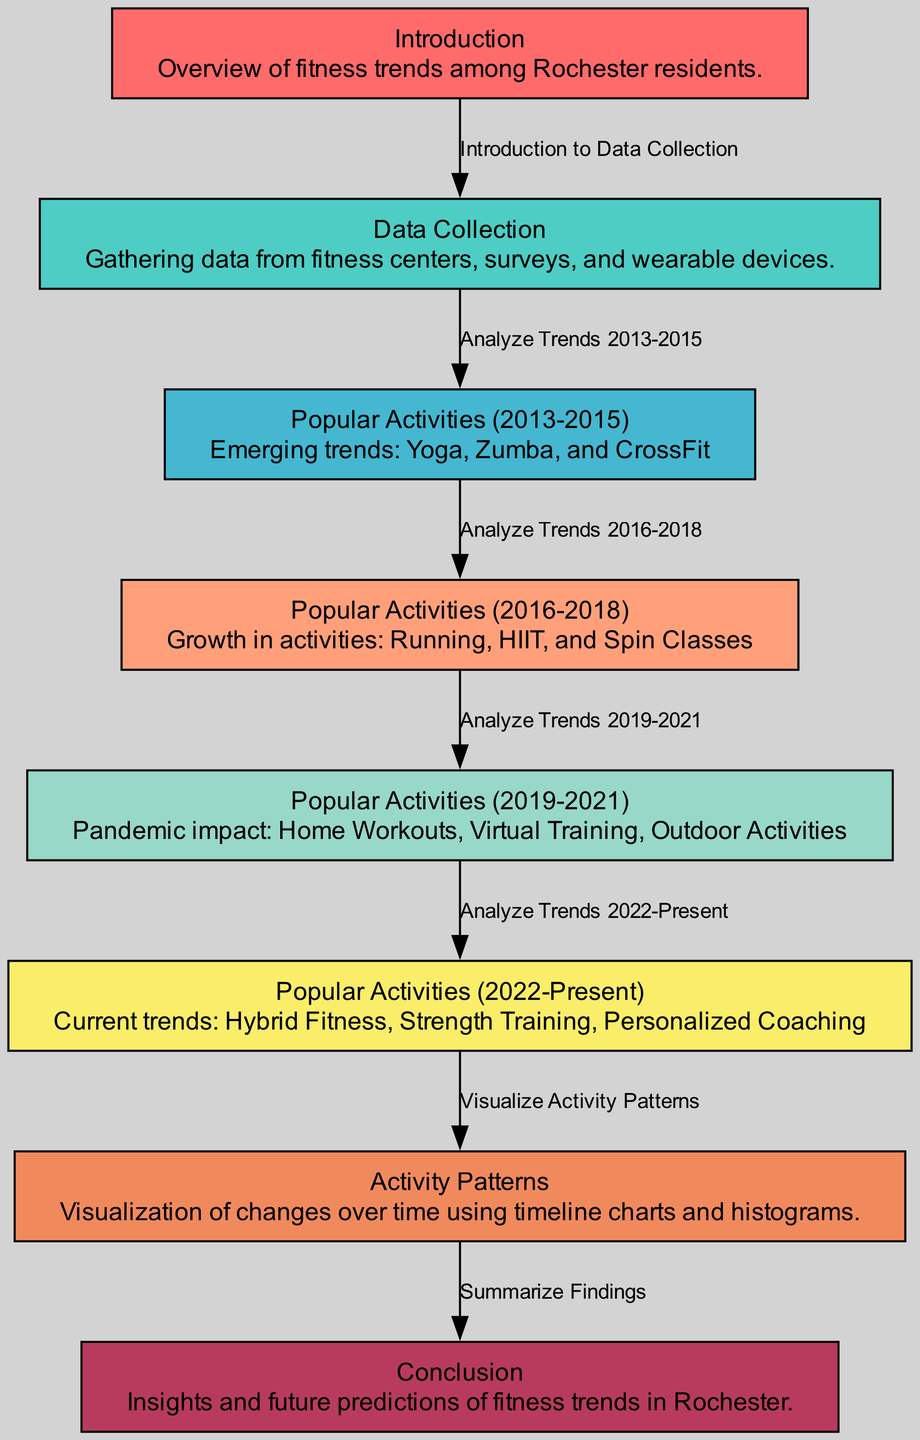What is the label of the first node in the diagram? The first node in the diagram is labeled "Introduction" as stated in the node description.
Answer: Introduction How many nodes are present in the diagram? By counting the entries under the "nodes" section in the data, there are a total of eight nodes in the diagram.
Answer: 8 What is the relationship between the "Data Collection" and "Popular Activities (2013-2015)" nodes? The "Data Collection" node points to "Popular Activities (2013-2015)", indicating that the analysis of trends from 2013 to 2015 follows the data collection process.
Answer: Analyze Trends 2013-2015 What fitness activities emerged as popular from 2013 to 2015? According to the "Popular Activities (2013-2015)" node, the emerging trends include Yoga, Zumba, and CrossFit.
Answer: Yoga, Zumba, and CrossFit What significant fitness change occurred between 2019 and 2021? The "Popular Activities (2019-2021)" node indicates that the pandemic impacted trends, leading to growth in Home Workouts, Virtual Training, and Outdoor Activities during this time.
Answer: Home Workouts, Virtual Training, Outdoor Activities Which node discusses visualization techniques? The "Activity Patterns" node in the diagram specifically addresses the visualization of changes over time using timeline charts and histograms.
Answer: Activity Patterns What is the final step after visualizing activity patterns? After visualizing activity patterns, the diagram progresses to the conclusion which summarizes the findings regarding fitness trends in Rochester.
Answer: Summarize Findings What type of fitness trend is highlighted from 2022 to the present? The "Popular Activities (2022-Present)" node indicates that current trends include Hybrid Fitness, Strength Training, and Personalized Coaching.
Answer: Hybrid Fitness, Strength Training, Personalized Coaching How does the diagram show the progression of fitness trends over time? The structure of the diagram illustrates a sequential flow from data collection through various nodes detailing popular activities in defined periods, culminating in visual representation and conclusions, highlighting trends over the decade.
Answer: Sequential Flow 